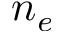<formula> <loc_0><loc_0><loc_500><loc_500>n _ { e }</formula> 